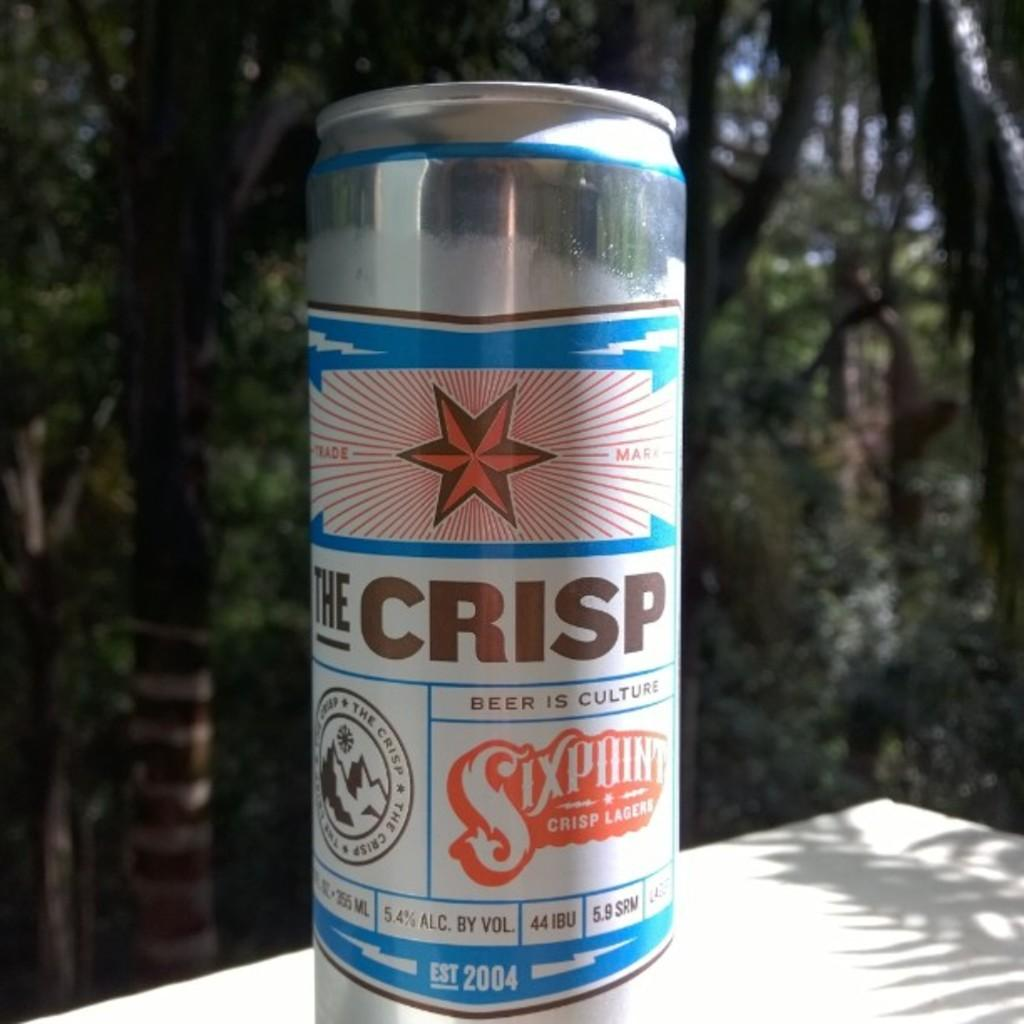<image>
Create a compact narrative representing the image presented. A can of beer that says The Crisp on it. 